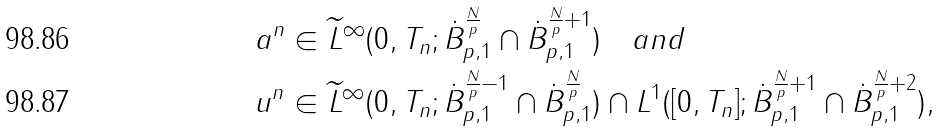Convert formula to latex. <formula><loc_0><loc_0><loc_500><loc_500>& a ^ { n } \in \widetilde { L } ^ { \infty } ( 0 , T _ { n } ; \dot { B } ^ { \frac { N } { p } } _ { p , 1 } \cap \dot { B } ^ { \frac { N } { p } + 1 } _ { p , 1 } ) \quad a n d \\ & u ^ { n } \in \widetilde { L } ^ { \infty } ( 0 , T _ { n } ; \dot { B } ^ { \frac { N } { p } - 1 } _ { p , 1 } \cap \dot { B } ^ { \frac { N } { p } } _ { p , 1 } ) \cap L ^ { 1 } ( [ 0 , T _ { n } ] ; \dot { B } ^ { \frac { N } { p } + 1 } _ { p , 1 } \cap \dot { B } ^ { \frac { N } { p } + 2 } _ { p , 1 } ) ,</formula> 